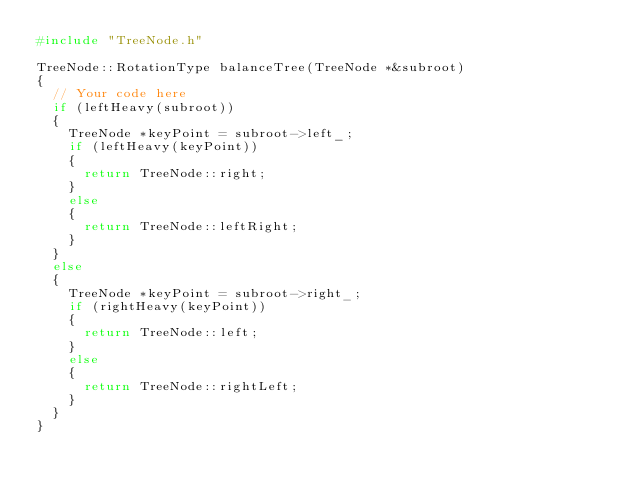Convert code to text. <code><loc_0><loc_0><loc_500><loc_500><_C++_>#include "TreeNode.h"

TreeNode::RotationType balanceTree(TreeNode *&subroot)
{
  // Your code here
  if (leftHeavy(subroot))
  {
    TreeNode *keyPoint = subroot->left_;
    if (leftHeavy(keyPoint))
    {
      return TreeNode::right;
    }
    else
    {
      return TreeNode::leftRight;
    }
  }
  else
  {
    TreeNode *keyPoint = subroot->right_;
    if (rightHeavy(keyPoint))
    {
      return TreeNode::left;
    }
    else
    {
      return TreeNode::rightLeft;
    }
  }
}
</code> 